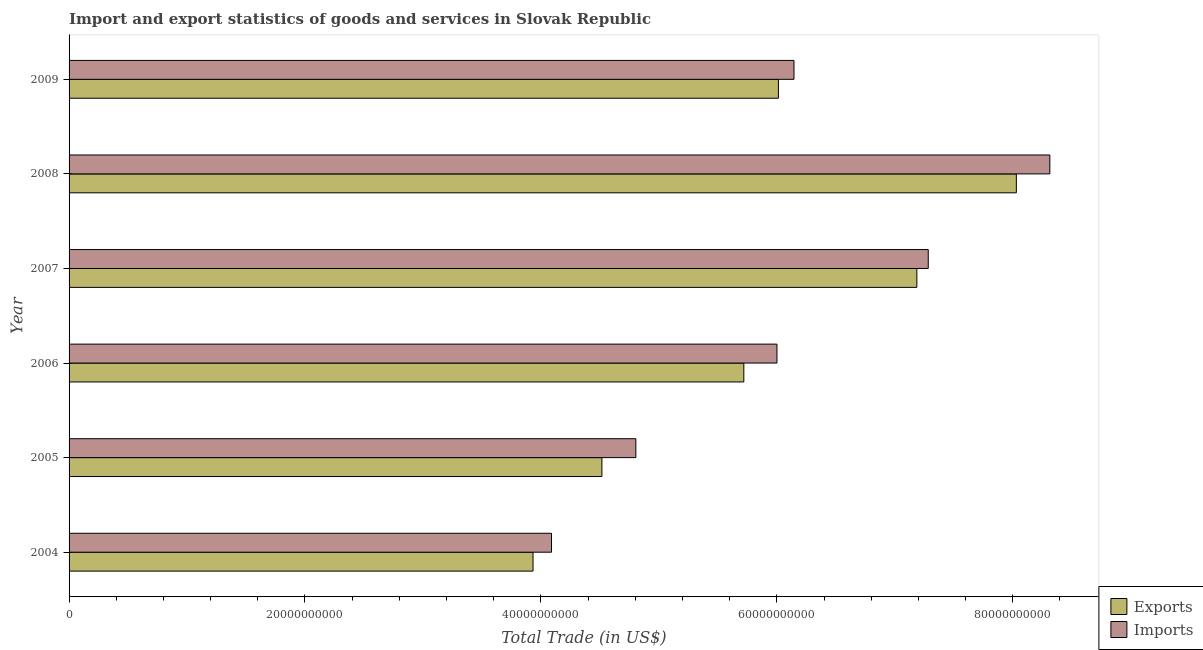How many bars are there on the 6th tick from the top?
Your answer should be very brief. 2. What is the label of the 4th group of bars from the top?
Give a very brief answer. 2006. What is the imports of goods and services in 2008?
Offer a terse response. 8.31e+1. Across all years, what is the maximum imports of goods and services?
Provide a short and direct response. 8.31e+1. Across all years, what is the minimum imports of goods and services?
Make the answer very short. 4.09e+1. In which year was the imports of goods and services maximum?
Give a very brief answer. 2008. In which year was the imports of goods and services minimum?
Offer a very short reply. 2004. What is the total imports of goods and services in the graph?
Give a very brief answer. 3.66e+11. What is the difference between the imports of goods and services in 2006 and that in 2007?
Give a very brief answer. -1.28e+1. What is the difference between the imports of goods and services in 2008 and the export of goods and services in 2006?
Your answer should be very brief. 2.59e+1. What is the average imports of goods and services per year?
Provide a succinct answer. 6.11e+1. In the year 2004, what is the difference between the imports of goods and services and export of goods and services?
Make the answer very short. 1.57e+09. What is the ratio of the imports of goods and services in 2005 to that in 2006?
Offer a terse response. 0.8. Is the difference between the imports of goods and services in 2007 and 2008 greater than the difference between the export of goods and services in 2007 and 2008?
Your response must be concise. No. What is the difference between the highest and the second highest imports of goods and services?
Offer a terse response. 1.03e+1. What is the difference between the highest and the lowest export of goods and services?
Make the answer very short. 4.10e+1. In how many years, is the export of goods and services greater than the average export of goods and services taken over all years?
Provide a succinct answer. 3. Is the sum of the export of goods and services in 2006 and 2009 greater than the maximum imports of goods and services across all years?
Ensure brevity in your answer.  Yes. What does the 1st bar from the top in 2005 represents?
Make the answer very short. Imports. What does the 2nd bar from the bottom in 2007 represents?
Your answer should be compact. Imports. Are all the bars in the graph horizontal?
Offer a terse response. Yes. How many years are there in the graph?
Make the answer very short. 6. What is the difference between two consecutive major ticks on the X-axis?
Provide a succinct answer. 2.00e+1. Are the values on the major ticks of X-axis written in scientific E-notation?
Offer a very short reply. No. Where does the legend appear in the graph?
Make the answer very short. Bottom right. How are the legend labels stacked?
Your response must be concise. Vertical. What is the title of the graph?
Your answer should be compact. Import and export statistics of goods and services in Slovak Republic. What is the label or title of the X-axis?
Keep it short and to the point. Total Trade (in US$). What is the label or title of the Y-axis?
Provide a succinct answer. Year. What is the Total Trade (in US$) in Exports in 2004?
Keep it short and to the point. 3.93e+1. What is the Total Trade (in US$) of Imports in 2004?
Give a very brief answer. 4.09e+1. What is the Total Trade (in US$) in Exports in 2005?
Your answer should be very brief. 4.52e+1. What is the Total Trade (in US$) in Imports in 2005?
Your answer should be very brief. 4.80e+1. What is the Total Trade (in US$) of Exports in 2006?
Keep it short and to the point. 5.72e+1. What is the Total Trade (in US$) in Imports in 2006?
Keep it short and to the point. 6.00e+1. What is the Total Trade (in US$) of Exports in 2007?
Provide a succinct answer. 7.19e+1. What is the Total Trade (in US$) in Imports in 2007?
Provide a succinct answer. 7.28e+1. What is the Total Trade (in US$) in Exports in 2008?
Offer a very short reply. 8.03e+1. What is the Total Trade (in US$) in Imports in 2008?
Make the answer very short. 8.31e+1. What is the Total Trade (in US$) in Exports in 2009?
Provide a short and direct response. 6.01e+1. What is the Total Trade (in US$) of Imports in 2009?
Offer a terse response. 6.15e+1. Across all years, what is the maximum Total Trade (in US$) of Exports?
Keep it short and to the point. 8.03e+1. Across all years, what is the maximum Total Trade (in US$) of Imports?
Give a very brief answer. 8.31e+1. Across all years, what is the minimum Total Trade (in US$) in Exports?
Keep it short and to the point. 3.93e+1. Across all years, what is the minimum Total Trade (in US$) in Imports?
Offer a very short reply. 4.09e+1. What is the total Total Trade (in US$) of Exports in the graph?
Offer a very short reply. 3.54e+11. What is the total Total Trade (in US$) of Imports in the graph?
Offer a terse response. 3.66e+11. What is the difference between the Total Trade (in US$) of Exports in 2004 and that in 2005?
Your response must be concise. -5.84e+09. What is the difference between the Total Trade (in US$) in Imports in 2004 and that in 2005?
Provide a succinct answer. -7.15e+09. What is the difference between the Total Trade (in US$) in Exports in 2004 and that in 2006?
Your response must be concise. -1.79e+1. What is the difference between the Total Trade (in US$) of Imports in 2004 and that in 2006?
Keep it short and to the point. -1.91e+1. What is the difference between the Total Trade (in US$) in Exports in 2004 and that in 2007?
Make the answer very short. -3.25e+1. What is the difference between the Total Trade (in US$) of Imports in 2004 and that in 2007?
Provide a short and direct response. -3.19e+1. What is the difference between the Total Trade (in US$) in Exports in 2004 and that in 2008?
Offer a terse response. -4.10e+1. What is the difference between the Total Trade (in US$) in Imports in 2004 and that in 2008?
Provide a short and direct response. -4.22e+1. What is the difference between the Total Trade (in US$) in Exports in 2004 and that in 2009?
Your response must be concise. -2.08e+1. What is the difference between the Total Trade (in US$) of Imports in 2004 and that in 2009?
Give a very brief answer. -2.06e+1. What is the difference between the Total Trade (in US$) of Exports in 2005 and that in 2006?
Give a very brief answer. -1.20e+1. What is the difference between the Total Trade (in US$) in Imports in 2005 and that in 2006?
Offer a terse response. -1.20e+1. What is the difference between the Total Trade (in US$) of Exports in 2005 and that in 2007?
Ensure brevity in your answer.  -2.67e+1. What is the difference between the Total Trade (in US$) in Imports in 2005 and that in 2007?
Provide a short and direct response. -2.48e+1. What is the difference between the Total Trade (in US$) of Exports in 2005 and that in 2008?
Provide a short and direct response. -3.51e+1. What is the difference between the Total Trade (in US$) in Imports in 2005 and that in 2008?
Provide a succinct answer. -3.51e+1. What is the difference between the Total Trade (in US$) in Exports in 2005 and that in 2009?
Your answer should be very brief. -1.50e+1. What is the difference between the Total Trade (in US$) in Imports in 2005 and that in 2009?
Offer a very short reply. -1.34e+1. What is the difference between the Total Trade (in US$) of Exports in 2006 and that in 2007?
Offer a terse response. -1.47e+1. What is the difference between the Total Trade (in US$) of Imports in 2006 and that in 2007?
Offer a very short reply. -1.28e+1. What is the difference between the Total Trade (in US$) of Exports in 2006 and that in 2008?
Give a very brief answer. -2.31e+1. What is the difference between the Total Trade (in US$) of Imports in 2006 and that in 2008?
Make the answer very short. -2.31e+1. What is the difference between the Total Trade (in US$) in Exports in 2006 and that in 2009?
Give a very brief answer. -2.93e+09. What is the difference between the Total Trade (in US$) in Imports in 2006 and that in 2009?
Provide a short and direct response. -1.44e+09. What is the difference between the Total Trade (in US$) in Exports in 2007 and that in 2008?
Your answer should be compact. -8.43e+09. What is the difference between the Total Trade (in US$) of Imports in 2007 and that in 2008?
Keep it short and to the point. -1.03e+1. What is the difference between the Total Trade (in US$) in Exports in 2007 and that in 2009?
Make the answer very short. 1.17e+1. What is the difference between the Total Trade (in US$) in Imports in 2007 and that in 2009?
Offer a terse response. 1.14e+1. What is the difference between the Total Trade (in US$) in Exports in 2008 and that in 2009?
Make the answer very short. 2.02e+1. What is the difference between the Total Trade (in US$) in Imports in 2008 and that in 2009?
Keep it short and to the point. 2.17e+1. What is the difference between the Total Trade (in US$) in Exports in 2004 and the Total Trade (in US$) in Imports in 2005?
Provide a succinct answer. -8.72e+09. What is the difference between the Total Trade (in US$) of Exports in 2004 and the Total Trade (in US$) of Imports in 2006?
Provide a succinct answer. -2.07e+1. What is the difference between the Total Trade (in US$) of Exports in 2004 and the Total Trade (in US$) of Imports in 2007?
Give a very brief answer. -3.35e+1. What is the difference between the Total Trade (in US$) in Exports in 2004 and the Total Trade (in US$) in Imports in 2008?
Give a very brief answer. -4.38e+1. What is the difference between the Total Trade (in US$) of Exports in 2004 and the Total Trade (in US$) of Imports in 2009?
Give a very brief answer. -2.21e+1. What is the difference between the Total Trade (in US$) in Exports in 2005 and the Total Trade (in US$) in Imports in 2006?
Make the answer very short. -1.48e+1. What is the difference between the Total Trade (in US$) of Exports in 2005 and the Total Trade (in US$) of Imports in 2007?
Give a very brief answer. -2.77e+1. What is the difference between the Total Trade (in US$) of Exports in 2005 and the Total Trade (in US$) of Imports in 2008?
Ensure brevity in your answer.  -3.80e+1. What is the difference between the Total Trade (in US$) in Exports in 2005 and the Total Trade (in US$) in Imports in 2009?
Offer a terse response. -1.63e+1. What is the difference between the Total Trade (in US$) of Exports in 2006 and the Total Trade (in US$) of Imports in 2007?
Give a very brief answer. -1.56e+1. What is the difference between the Total Trade (in US$) in Exports in 2006 and the Total Trade (in US$) in Imports in 2008?
Provide a succinct answer. -2.59e+1. What is the difference between the Total Trade (in US$) in Exports in 2006 and the Total Trade (in US$) in Imports in 2009?
Make the answer very short. -4.25e+09. What is the difference between the Total Trade (in US$) in Exports in 2007 and the Total Trade (in US$) in Imports in 2008?
Make the answer very short. -1.13e+1. What is the difference between the Total Trade (in US$) of Exports in 2007 and the Total Trade (in US$) of Imports in 2009?
Offer a very short reply. 1.04e+1. What is the difference between the Total Trade (in US$) of Exports in 2008 and the Total Trade (in US$) of Imports in 2009?
Provide a succinct answer. 1.89e+1. What is the average Total Trade (in US$) in Exports per year?
Provide a succinct answer. 5.90e+1. What is the average Total Trade (in US$) in Imports per year?
Your answer should be very brief. 6.11e+1. In the year 2004, what is the difference between the Total Trade (in US$) in Exports and Total Trade (in US$) in Imports?
Provide a succinct answer. -1.57e+09. In the year 2005, what is the difference between the Total Trade (in US$) in Exports and Total Trade (in US$) in Imports?
Your response must be concise. -2.88e+09. In the year 2006, what is the difference between the Total Trade (in US$) in Exports and Total Trade (in US$) in Imports?
Provide a succinct answer. -2.81e+09. In the year 2007, what is the difference between the Total Trade (in US$) of Exports and Total Trade (in US$) of Imports?
Offer a very short reply. -9.66e+08. In the year 2008, what is the difference between the Total Trade (in US$) in Exports and Total Trade (in US$) in Imports?
Give a very brief answer. -2.84e+09. In the year 2009, what is the difference between the Total Trade (in US$) of Exports and Total Trade (in US$) of Imports?
Keep it short and to the point. -1.32e+09. What is the ratio of the Total Trade (in US$) of Exports in 2004 to that in 2005?
Make the answer very short. 0.87. What is the ratio of the Total Trade (in US$) of Imports in 2004 to that in 2005?
Offer a very short reply. 0.85. What is the ratio of the Total Trade (in US$) of Exports in 2004 to that in 2006?
Make the answer very short. 0.69. What is the ratio of the Total Trade (in US$) in Imports in 2004 to that in 2006?
Your answer should be very brief. 0.68. What is the ratio of the Total Trade (in US$) of Exports in 2004 to that in 2007?
Keep it short and to the point. 0.55. What is the ratio of the Total Trade (in US$) of Imports in 2004 to that in 2007?
Provide a succinct answer. 0.56. What is the ratio of the Total Trade (in US$) of Exports in 2004 to that in 2008?
Offer a terse response. 0.49. What is the ratio of the Total Trade (in US$) of Imports in 2004 to that in 2008?
Your answer should be compact. 0.49. What is the ratio of the Total Trade (in US$) of Exports in 2004 to that in 2009?
Your answer should be very brief. 0.65. What is the ratio of the Total Trade (in US$) of Imports in 2004 to that in 2009?
Provide a succinct answer. 0.67. What is the ratio of the Total Trade (in US$) in Exports in 2005 to that in 2006?
Your response must be concise. 0.79. What is the ratio of the Total Trade (in US$) of Imports in 2005 to that in 2006?
Your answer should be very brief. 0.8. What is the ratio of the Total Trade (in US$) in Exports in 2005 to that in 2007?
Your answer should be compact. 0.63. What is the ratio of the Total Trade (in US$) in Imports in 2005 to that in 2007?
Provide a short and direct response. 0.66. What is the ratio of the Total Trade (in US$) in Exports in 2005 to that in 2008?
Offer a terse response. 0.56. What is the ratio of the Total Trade (in US$) in Imports in 2005 to that in 2008?
Give a very brief answer. 0.58. What is the ratio of the Total Trade (in US$) of Exports in 2005 to that in 2009?
Give a very brief answer. 0.75. What is the ratio of the Total Trade (in US$) in Imports in 2005 to that in 2009?
Make the answer very short. 0.78. What is the ratio of the Total Trade (in US$) in Exports in 2006 to that in 2007?
Keep it short and to the point. 0.8. What is the ratio of the Total Trade (in US$) of Imports in 2006 to that in 2007?
Provide a succinct answer. 0.82. What is the ratio of the Total Trade (in US$) in Exports in 2006 to that in 2008?
Offer a terse response. 0.71. What is the ratio of the Total Trade (in US$) in Imports in 2006 to that in 2008?
Offer a very short reply. 0.72. What is the ratio of the Total Trade (in US$) of Exports in 2006 to that in 2009?
Provide a short and direct response. 0.95. What is the ratio of the Total Trade (in US$) of Imports in 2006 to that in 2009?
Make the answer very short. 0.98. What is the ratio of the Total Trade (in US$) of Exports in 2007 to that in 2008?
Offer a terse response. 0.9. What is the ratio of the Total Trade (in US$) of Imports in 2007 to that in 2008?
Provide a short and direct response. 0.88. What is the ratio of the Total Trade (in US$) in Exports in 2007 to that in 2009?
Your response must be concise. 1.2. What is the ratio of the Total Trade (in US$) of Imports in 2007 to that in 2009?
Keep it short and to the point. 1.19. What is the ratio of the Total Trade (in US$) of Exports in 2008 to that in 2009?
Your answer should be very brief. 1.34. What is the ratio of the Total Trade (in US$) of Imports in 2008 to that in 2009?
Your response must be concise. 1.35. What is the difference between the highest and the second highest Total Trade (in US$) of Exports?
Offer a terse response. 8.43e+09. What is the difference between the highest and the second highest Total Trade (in US$) in Imports?
Make the answer very short. 1.03e+1. What is the difference between the highest and the lowest Total Trade (in US$) in Exports?
Offer a terse response. 4.10e+1. What is the difference between the highest and the lowest Total Trade (in US$) in Imports?
Offer a terse response. 4.22e+1. 